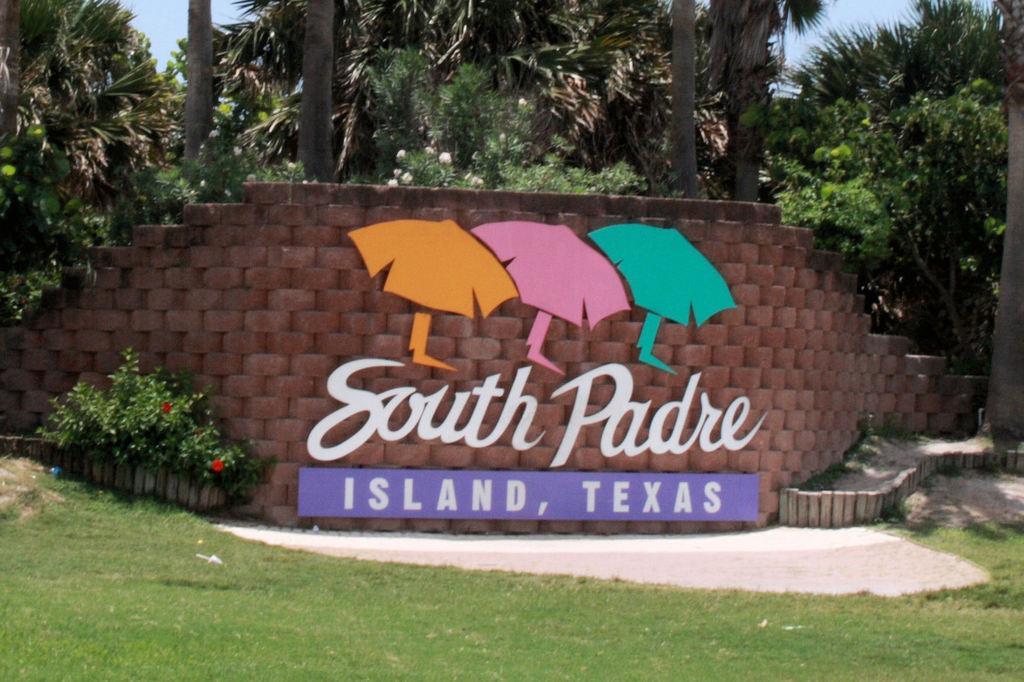How would you summarize this image in a sentence or two? In the center of the image we can see the text on the wall and board. In the background of the image we can see the trees, plants, flowers, bricks, grass. At the bottom of the image we can see the ground. At the top of the image we can see the sky. 